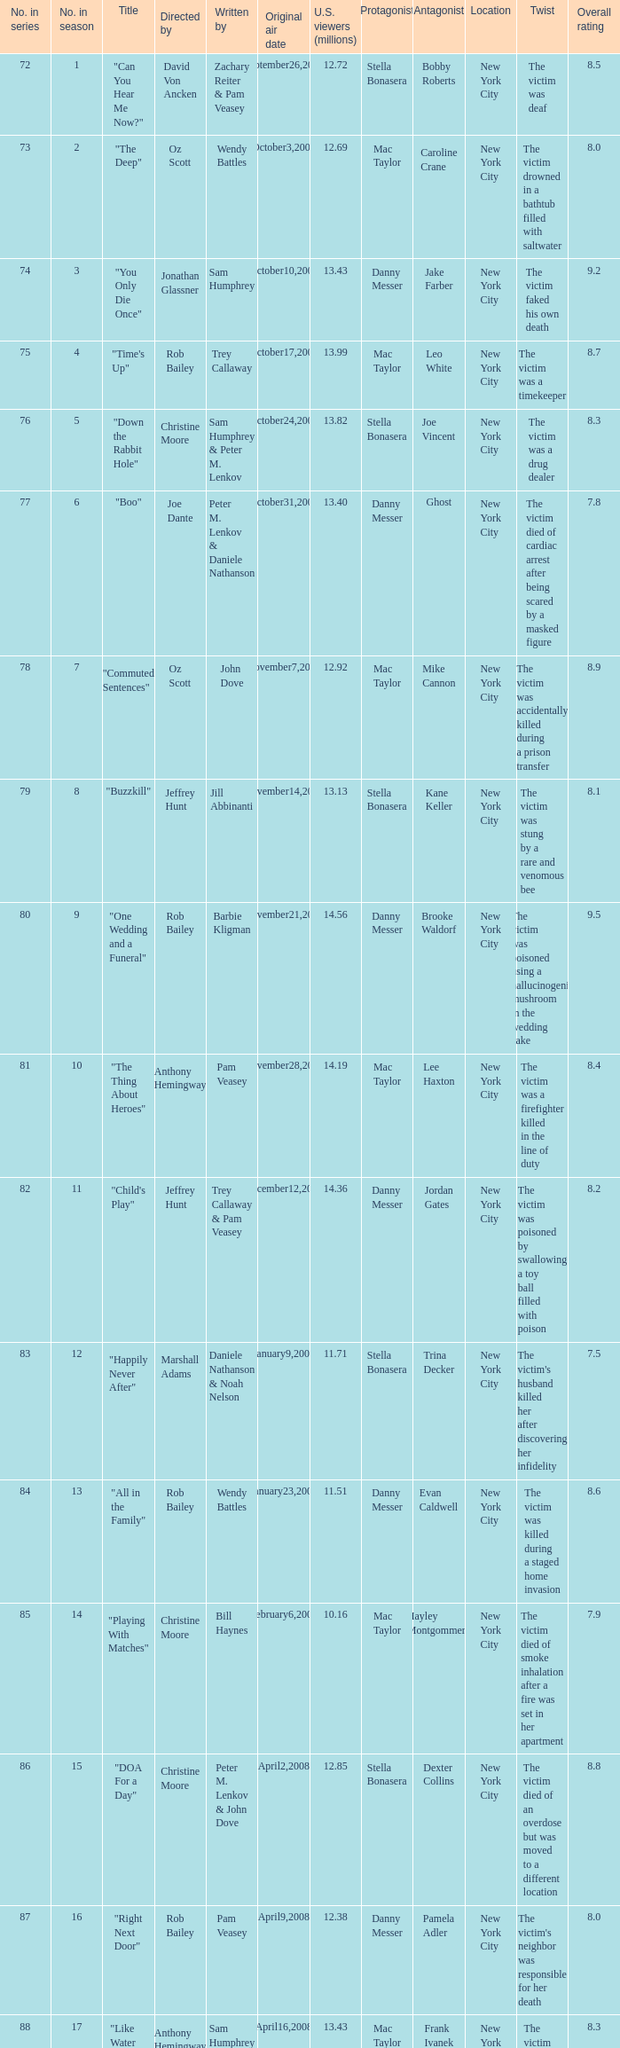Would you be able to parse every entry in this table? {'header': ['No. in series', 'No. in season', 'Title', 'Directed by', 'Written by', 'Original air date', 'U.S. viewers (millions)', 'Protagonist', 'Antagonist', 'Location', 'Twist', 'Overall rating'], 'rows': [['72', '1', '"Can You Hear Me Now?"', 'David Von Ancken', 'Zachary Reiter & Pam Veasey', 'September26,2007', '12.72', 'Stella Bonasera', 'Bobby Roberts', 'New York City', 'The victim was deaf', '8.5'], ['73', '2', '"The Deep"', 'Oz Scott', 'Wendy Battles', 'October3,2007', '12.69', 'Mac Taylor', 'Caroline Crane', 'New York City', 'The victim drowned in a bathtub filled with saltwater', '8.0'], ['74', '3', '"You Only Die Once"', 'Jonathan Glassner', 'Sam Humphrey', 'October10,2007', '13.43', 'Danny Messer', 'Jake Farber', 'New York City', 'The victim faked his own death', '9.2'], ['75', '4', '"Time\'s Up"', 'Rob Bailey', 'Trey Callaway', 'October17,2007', '13.99', 'Mac Taylor', 'Leo White', 'New York City', 'The victim was a timekeeper', '8.7'], ['76', '5', '"Down the Rabbit Hole"', 'Christine Moore', 'Sam Humphrey & Peter M. Lenkov', 'October24,2007', '13.82', 'Stella Bonasera', 'Joe Vincent', 'New York City', 'The victim was a drug dealer', '8.3'], ['77', '6', '"Boo"', 'Joe Dante', 'Peter M. Lenkov & Daniele Nathanson', 'October31,2007', '13.40', 'Danny Messer', 'Ghost', 'New York City', 'The victim died of cardiac arrest after being scared by a masked figure', '7.8'], ['78', '7', '"Commuted Sentences"', 'Oz Scott', 'John Dove', 'November7,2007', '12.92', 'Mac Taylor', 'Mike Cannon', 'New York City', 'The victim was accidentally killed during a prison transfer', '8.9'], ['79', '8', '"Buzzkill"', 'Jeffrey Hunt', 'Jill Abbinanti', 'November14,2007', '13.13', 'Stella Bonasera', 'Kane Keller', 'New York City', 'The victim was stung by a rare and venomous bee', '8.1'], ['80', '9', '"One Wedding and a Funeral"', 'Rob Bailey', 'Barbie Kligman', 'November21,2007', '14.56', 'Danny Messer', 'Brooke Waldorf', 'New York City', 'The victim was poisoned using a hallucinogenic mushroom in the wedding cake', '9.5'], ['81', '10', '"The Thing About Heroes"', 'Anthony Hemingway', 'Pam Veasey', 'November28,2007', '14.19', 'Mac Taylor', 'Lee Haxton', 'New York City', 'The victim was a firefighter killed in the line of duty', '8.4'], ['82', '11', '"Child\'s Play"', 'Jeffrey Hunt', 'Trey Callaway & Pam Veasey', 'December12,2007', '14.36', 'Danny Messer', 'Jordan Gates', 'New York City', 'The victim was poisoned by swallowing a toy ball filled with poison', '8.2'], ['83', '12', '"Happily Never After"', 'Marshall Adams', 'Daniele Nathanson & Noah Nelson', 'January9,2008', '11.71', 'Stella Bonasera', 'Trina Decker', 'New York City', "The victim's husband killed her after discovering her infidelity", '7.5'], ['84', '13', '"All in the Family"', 'Rob Bailey', 'Wendy Battles', 'January23,2008', '11.51', 'Danny Messer', 'Evan Caldwell', 'New York City', 'The victim was killed during a staged home invasion', '8.6'], ['85', '14', '"Playing With Matches"', 'Christine Moore', 'Bill Haynes', 'February6,2008', '10.16', 'Mac Taylor', 'Hayley Montgommery', 'New York City', 'The victim died of smoke inhalation after a fire was set in her apartment', '7.9'], ['86', '15', '"DOA For a Day"', 'Christine Moore', 'Peter M. Lenkov & John Dove', 'April2,2008', '12.85', 'Stella Bonasera', 'Dexter Collins', 'New York City', 'The victim died of an overdose but was moved to a different location', '8.8'], ['87', '16', '"Right Next Door"', 'Rob Bailey', 'Pam Veasey', 'April9,2008', '12.38', 'Danny Messer', 'Pamela Adler', 'New York City', "The victim's neighbor was responsible for her death", '8.0'], ['88', '17', '"Like Water For Murder"', 'Anthony Hemingway', 'Sam Humphrey', 'April16,2008', '13.43', 'Mac Taylor', 'Frank Ivanek', 'New York City', 'The victim was drowned in a bathtub filled with olive oil', '8.3'], ['89', '18', '"Admissions"', 'Rob Bailey', 'Zachary Reiter', 'April30,2008', '11.51', 'Stella Bonasera', 'Heather Kessler', 'New York City', 'The victim was killed by an unknown pathogen', '7.6'], ['90', '19', '"Personal Foul"', 'David Von Ancken', 'Trey Callaway', 'May7,2008', '12.73', 'Danny Messer', 'Clay Dobson', 'New York City', 'The victim was a high school basketball coach killed over a recruiting scandal', '8.9'], ['91', '20', '"Taxi"', 'Christine Moore', 'Barbie Kligman & John Dove', 'May14,2008', '11.86', 'Mac Taylor', 'Reynaldo Cortez', 'New York City', 'The victim was a taxi driver killed during a robbery gone wrong', '8.1']]} How many millions of U.S. viewers watched the episode "Buzzkill"?  1.0. 